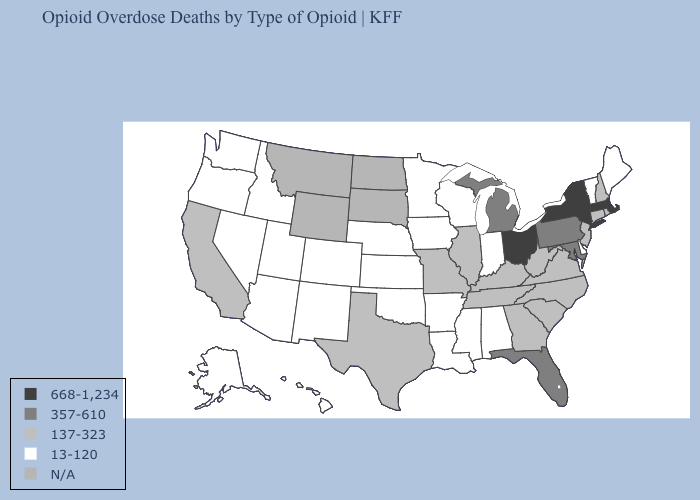Name the states that have a value in the range N/A?
Short answer required. Montana, North Dakota, South Dakota, Wyoming. Among the states that border Ohio , does Indiana have the lowest value?
Give a very brief answer. Yes. Does the map have missing data?
Write a very short answer. Yes. Which states have the lowest value in the USA?
Concise answer only. Alabama, Alaska, Arizona, Arkansas, Colorado, Delaware, Hawaii, Idaho, Indiana, Iowa, Kansas, Louisiana, Maine, Minnesota, Mississippi, Nebraska, Nevada, New Mexico, Oklahoma, Oregon, Utah, Vermont, Washington, Wisconsin. Name the states that have a value in the range 357-610?
Short answer required. Florida, Maryland, Michigan, Pennsylvania. Which states have the lowest value in the USA?
Keep it brief. Alabama, Alaska, Arizona, Arkansas, Colorado, Delaware, Hawaii, Idaho, Indiana, Iowa, Kansas, Louisiana, Maine, Minnesota, Mississippi, Nebraska, Nevada, New Mexico, Oklahoma, Oregon, Utah, Vermont, Washington, Wisconsin. What is the highest value in states that border Tennessee?
Keep it brief. 137-323. How many symbols are there in the legend?
Short answer required. 5. Name the states that have a value in the range 668-1,234?
Give a very brief answer. Massachusetts, New York, Ohio. What is the value of Missouri?
Short answer required. 137-323. Among the states that border Indiana , which have the lowest value?
Keep it brief. Illinois, Kentucky. Name the states that have a value in the range 137-323?
Write a very short answer. California, Connecticut, Georgia, Illinois, Kentucky, Missouri, New Hampshire, New Jersey, North Carolina, Rhode Island, South Carolina, Tennessee, Texas, Virginia, West Virginia. Which states have the lowest value in the South?
Be succinct. Alabama, Arkansas, Delaware, Louisiana, Mississippi, Oklahoma. What is the value of Colorado?
Keep it brief. 13-120. What is the highest value in the USA?
Answer briefly. 668-1,234. 